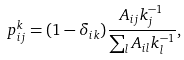<formula> <loc_0><loc_0><loc_500><loc_500>p _ { i j } ^ { k } = ( 1 - \delta _ { i k } ) \frac { A _ { i j } k _ { j } ^ { - 1 } } { \sum _ { l } A _ { i l } k _ { l } ^ { - 1 } } ,</formula> 